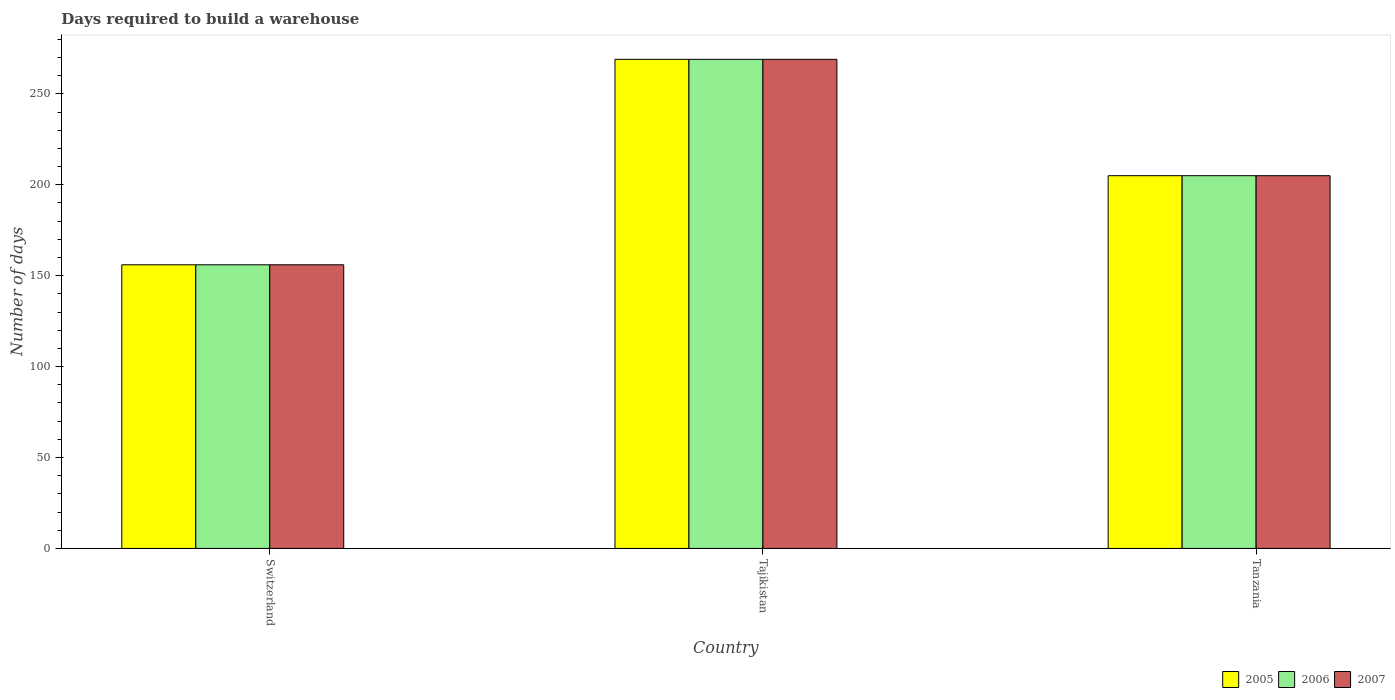How many different coloured bars are there?
Give a very brief answer. 3. How many groups of bars are there?
Ensure brevity in your answer.  3. What is the label of the 1st group of bars from the left?
Your answer should be compact. Switzerland. In how many cases, is the number of bars for a given country not equal to the number of legend labels?
Your answer should be very brief. 0. What is the days required to build a warehouse in in 2006 in Switzerland?
Your answer should be very brief. 156. Across all countries, what is the maximum days required to build a warehouse in in 2007?
Provide a succinct answer. 269. Across all countries, what is the minimum days required to build a warehouse in in 2006?
Your answer should be compact. 156. In which country was the days required to build a warehouse in in 2007 maximum?
Give a very brief answer. Tajikistan. In which country was the days required to build a warehouse in in 2006 minimum?
Provide a succinct answer. Switzerland. What is the total days required to build a warehouse in in 2006 in the graph?
Provide a short and direct response. 630. What is the difference between the days required to build a warehouse in in 2006 in Switzerland and that in Tajikistan?
Ensure brevity in your answer.  -113. What is the average days required to build a warehouse in in 2007 per country?
Offer a terse response. 210. What is the ratio of the days required to build a warehouse in in 2005 in Tajikistan to that in Tanzania?
Offer a terse response. 1.31. Is the difference between the days required to build a warehouse in in 2006 in Switzerland and Tajikistan greater than the difference between the days required to build a warehouse in in 2005 in Switzerland and Tajikistan?
Keep it short and to the point. No. What is the difference between the highest and the second highest days required to build a warehouse in in 2007?
Ensure brevity in your answer.  49. What is the difference between the highest and the lowest days required to build a warehouse in in 2005?
Ensure brevity in your answer.  113. In how many countries, is the days required to build a warehouse in in 2005 greater than the average days required to build a warehouse in in 2005 taken over all countries?
Offer a terse response. 1. Is it the case that in every country, the sum of the days required to build a warehouse in in 2005 and days required to build a warehouse in in 2007 is greater than the days required to build a warehouse in in 2006?
Your answer should be compact. Yes. How many bars are there?
Make the answer very short. 9. What is the difference between two consecutive major ticks on the Y-axis?
Your answer should be very brief. 50. Does the graph contain grids?
Ensure brevity in your answer.  No. How are the legend labels stacked?
Provide a short and direct response. Horizontal. What is the title of the graph?
Your response must be concise. Days required to build a warehouse. Does "2015" appear as one of the legend labels in the graph?
Keep it short and to the point. No. What is the label or title of the Y-axis?
Keep it short and to the point. Number of days. What is the Number of days of 2005 in Switzerland?
Keep it short and to the point. 156. What is the Number of days in 2006 in Switzerland?
Provide a short and direct response. 156. What is the Number of days in 2007 in Switzerland?
Offer a terse response. 156. What is the Number of days in 2005 in Tajikistan?
Keep it short and to the point. 269. What is the Number of days in 2006 in Tajikistan?
Ensure brevity in your answer.  269. What is the Number of days of 2007 in Tajikistan?
Ensure brevity in your answer.  269. What is the Number of days of 2005 in Tanzania?
Offer a terse response. 205. What is the Number of days in 2006 in Tanzania?
Give a very brief answer. 205. What is the Number of days in 2007 in Tanzania?
Ensure brevity in your answer.  205. Across all countries, what is the maximum Number of days in 2005?
Offer a terse response. 269. Across all countries, what is the maximum Number of days in 2006?
Make the answer very short. 269. Across all countries, what is the maximum Number of days in 2007?
Give a very brief answer. 269. Across all countries, what is the minimum Number of days of 2005?
Your response must be concise. 156. Across all countries, what is the minimum Number of days of 2006?
Provide a succinct answer. 156. Across all countries, what is the minimum Number of days of 2007?
Offer a very short reply. 156. What is the total Number of days in 2005 in the graph?
Keep it short and to the point. 630. What is the total Number of days in 2006 in the graph?
Keep it short and to the point. 630. What is the total Number of days of 2007 in the graph?
Provide a succinct answer. 630. What is the difference between the Number of days of 2005 in Switzerland and that in Tajikistan?
Your answer should be compact. -113. What is the difference between the Number of days of 2006 in Switzerland and that in Tajikistan?
Your response must be concise. -113. What is the difference between the Number of days of 2007 in Switzerland and that in Tajikistan?
Provide a succinct answer. -113. What is the difference between the Number of days in 2005 in Switzerland and that in Tanzania?
Offer a terse response. -49. What is the difference between the Number of days in 2006 in Switzerland and that in Tanzania?
Your answer should be compact. -49. What is the difference between the Number of days of 2007 in Switzerland and that in Tanzania?
Offer a terse response. -49. What is the difference between the Number of days in 2006 in Tajikistan and that in Tanzania?
Your answer should be very brief. 64. What is the difference between the Number of days of 2007 in Tajikistan and that in Tanzania?
Provide a short and direct response. 64. What is the difference between the Number of days of 2005 in Switzerland and the Number of days of 2006 in Tajikistan?
Your answer should be compact. -113. What is the difference between the Number of days in 2005 in Switzerland and the Number of days in 2007 in Tajikistan?
Your answer should be very brief. -113. What is the difference between the Number of days of 2006 in Switzerland and the Number of days of 2007 in Tajikistan?
Give a very brief answer. -113. What is the difference between the Number of days in 2005 in Switzerland and the Number of days in 2006 in Tanzania?
Offer a very short reply. -49. What is the difference between the Number of days in 2005 in Switzerland and the Number of days in 2007 in Tanzania?
Make the answer very short. -49. What is the difference between the Number of days of 2006 in Switzerland and the Number of days of 2007 in Tanzania?
Offer a terse response. -49. What is the difference between the Number of days in 2006 in Tajikistan and the Number of days in 2007 in Tanzania?
Your response must be concise. 64. What is the average Number of days in 2005 per country?
Offer a very short reply. 210. What is the average Number of days of 2006 per country?
Keep it short and to the point. 210. What is the average Number of days of 2007 per country?
Ensure brevity in your answer.  210. What is the difference between the Number of days of 2005 and Number of days of 2006 in Switzerland?
Your answer should be compact. 0. What is the difference between the Number of days of 2005 and Number of days of 2006 in Tanzania?
Make the answer very short. 0. What is the difference between the Number of days in 2005 and Number of days in 2007 in Tanzania?
Offer a very short reply. 0. What is the difference between the Number of days in 2006 and Number of days in 2007 in Tanzania?
Your answer should be very brief. 0. What is the ratio of the Number of days in 2005 in Switzerland to that in Tajikistan?
Your answer should be compact. 0.58. What is the ratio of the Number of days of 2006 in Switzerland to that in Tajikistan?
Give a very brief answer. 0.58. What is the ratio of the Number of days of 2007 in Switzerland to that in Tajikistan?
Your answer should be compact. 0.58. What is the ratio of the Number of days of 2005 in Switzerland to that in Tanzania?
Your response must be concise. 0.76. What is the ratio of the Number of days of 2006 in Switzerland to that in Tanzania?
Offer a terse response. 0.76. What is the ratio of the Number of days of 2007 in Switzerland to that in Tanzania?
Provide a succinct answer. 0.76. What is the ratio of the Number of days in 2005 in Tajikistan to that in Tanzania?
Your answer should be compact. 1.31. What is the ratio of the Number of days in 2006 in Tajikistan to that in Tanzania?
Ensure brevity in your answer.  1.31. What is the ratio of the Number of days in 2007 in Tajikistan to that in Tanzania?
Provide a short and direct response. 1.31. What is the difference between the highest and the second highest Number of days of 2006?
Provide a short and direct response. 64. What is the difference between the highest and the second highest Number of days of 2007?
Make the answer very short. 64. What is the difference between the highest and the lowest Number of days of 2005?
Provide a short and direct response. 113. What is the difference between the highest and the lowest Number of days in 2006?
Offer a very short reply. 113. What is the difference between the highest and the lowest Number of days of 2007?
Your answer should be compact. 113. 